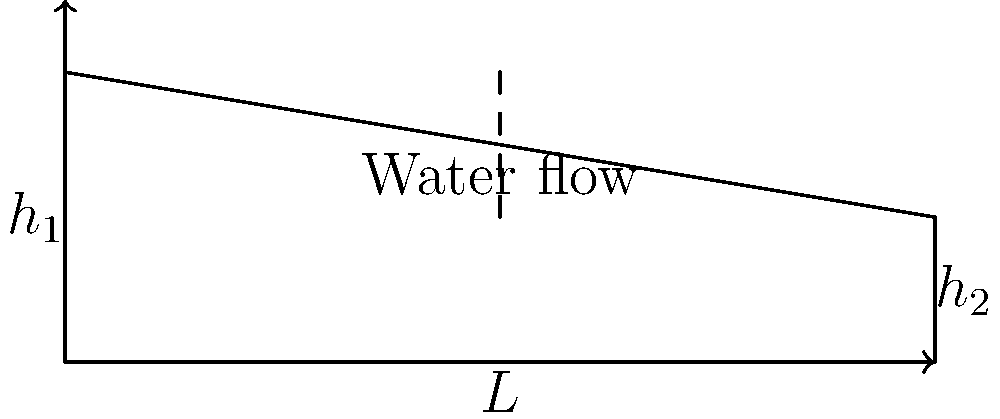You've constructed a sluice box for your gold panning operation, but you need to determine the flow rate of water through it. The sluice box is 6 feet long, with a water depth of 2 feet at the inlet and 1 foot at the outlet. Assuming a rectangular cross-section and using the Manning formula, calculate the flow rate in cubic feet per second (cfs) if the Manning's roughness coefficient is 0.012 and the width of the sluice box is 1.5 feet. To solve this problem, we'll use the Manning formula and follow these steps:

1. Calculate the slope of the water surface:
   Slope (S) = (h1 - h2) / L = (2 ft - 1 ft) / 6 ft = 1/6 = 0.1667

2. Calculate the average water depth:
   Average depth (d) = (h1 + h2) / 2 = (2 ft + 1 ft) / 2 = 1.5 ft

3. Calculate the wetted perimeter:
   Wetted perimeter (P) = width + 2 * average depth = 1.5 ft + 2 * 1.5 ft = 4.5 ft

4. Calculate the hydraulic radius:
   Hydraulic radius (R) = (width * average depth) / wetted perimeter
   R = (1.5 ft * 1.5 ft) / 4.5 ft = 0.5 ft

5. Apply the Manning formula:
   $$Q = \frac{1.49}{n} A R^{2/3} S^{1/2}$$
   Where:
   Q = flow rate (cfs)
   n = Manning's roughness coefficient (0.012)
   A = cross-sectional area (width * average depth = 1.5 ft * 1.5 ft = 2.25 sq ft)
   R = hydraulic radius (0.5 ft)
   S = slope (0.1667)

6. Substitute the values into the Manning formula:
   $$Q = \frac{1.49}{0.012} * 2.25 * (0.5)^{2/3} * (0.1667)^{1/2}$$

7. Calculate the result:
   Q ≈ 20.88 cfs
Answer: 20.88 cfs 